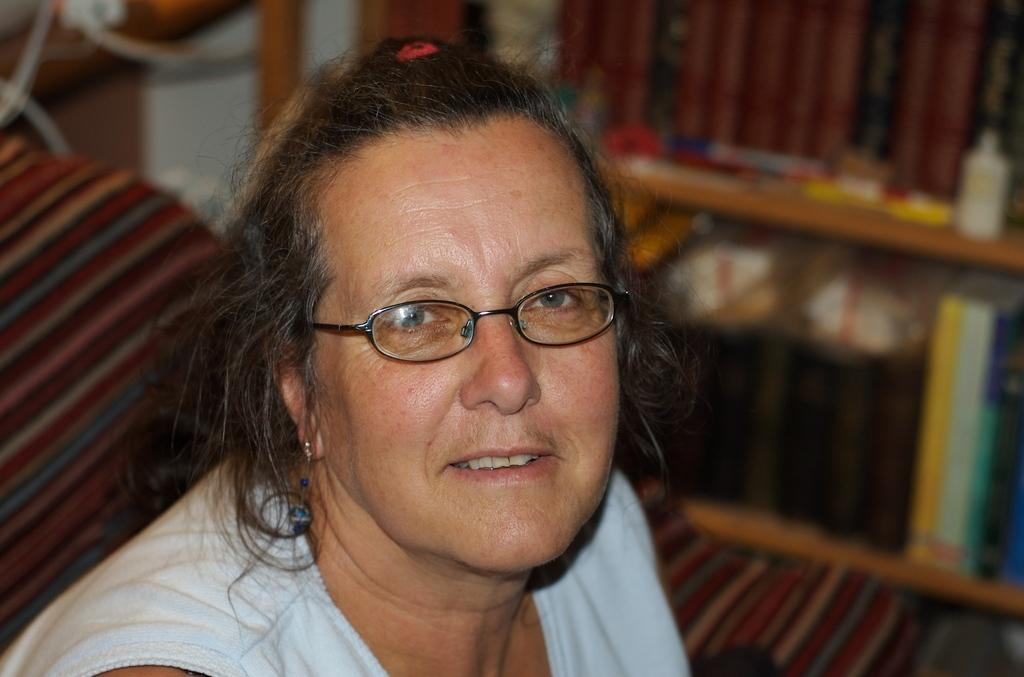Who is the main subject in the image? There is a woman in the middle of the picture. What is the woman wearing in the image? The woman is wearing spectacles. Can you describe the background of the image? The background of the image is blurred. What type of pig can be seen holding a spoon in the image? There is no pig or spoon present in the image; it features a woman wearing spectacles. How many balloons are visible in the image? There are no balloons present in the image. 